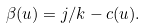<formula> <loc_0><loc_0><loc_500><loc_500>\beta ( u ) = j / k - c ( u ) .</formula> 